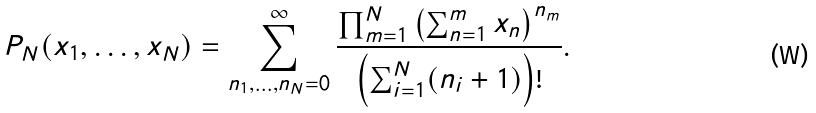Convert formula to latex. <formula><loc_0><loc_0><loc_500><loc_500>P _ { N } ( x _ { 1 } , \dots , x _ { N } ) = \sum _ { n _ { 1 } , \dots , n _ { N } = 0 } ^ { \infty } \frac { \prod _ { m = 1 } ^ { N } \left ( \sum _ { n = 1 } ^ { m } x _ { n } \right ) ^ { n _ { m } } } { \left ( \sum _ { i = 1 } ^ { N } ( n _ { i } + 1 ) \right ) ! } .</formula> 